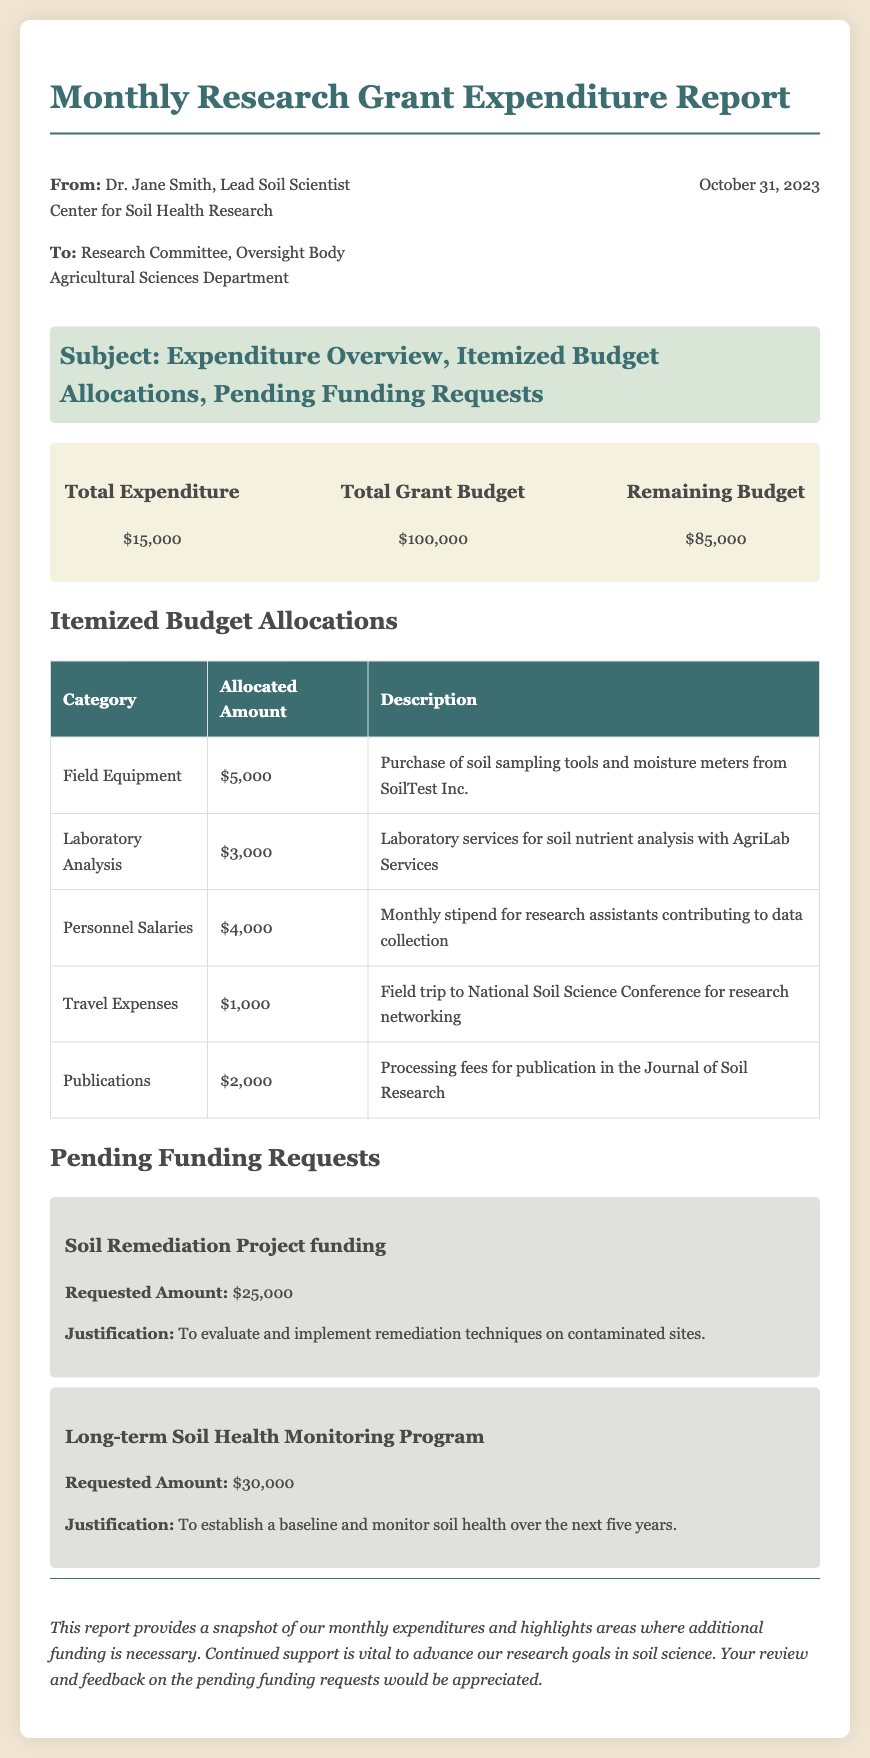What is the total expenditure? The total expenditure is detailed in the overview section of the document, which states it is $15,000.
Answer: $15,000 Who is the lead soil scientist? The name of the lead soil scientist is mentioned in the header, where it states Dr. Jane Smith.
Answer: Dr. Jane Smith What is the remaining budget? The remaining budget is calculated from the total grant budget minus the total expenditure, which is $100,000 - $15,000.
Answer: $85,000 How much is requested for the Soil Remediation Project? The requested amount for the Soil Remediation Project is listed under pending funding requests, which shows it is $25,000.
Answer: $25,000 What category has the highest allocated amount? The category with the highest allocated amount is indicated in the itemized budget allocations section, with Field Equipment being $5,000.
Answer: Field Equipment What is the justification for the Long-term Soil Health Monitoring Program funding request? The justification for the funding request is provided in the description for that project, which states it aims to establish a baseline and monitor soil health over five years.
Answer: To establish a baseline and monitor soil health over the next five years What service is associated with the $3,000 budget allocation? The service associated with this budget allocation is detailed in the itemized budget, referring to laboratory services for soil nutrient analysis with AgriLab Services.
Answer: Laboratory services for soil nutrient analysis with AgriLab Services What is the date of the report? The date of the report is included in the header section, noting that it is October 31, 2023.
Answer: October 31, 2023 